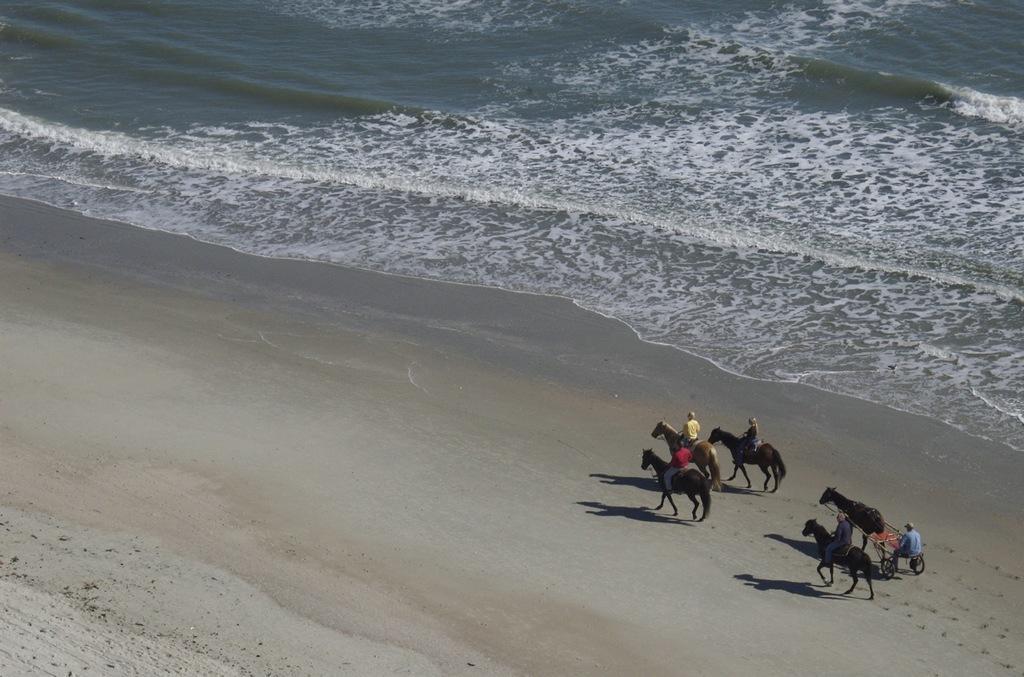Could you give a brief overview of what you see in this image? This is a beach. At the top of the image I can see the water. On the right side there are few people riding the horses and also there is one horse cart. 